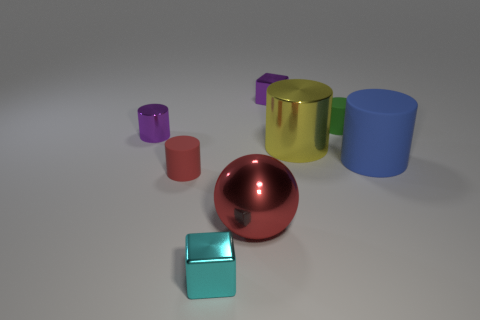Subtract all tiny green rubber cylinders. How many cylinders are left? 4 Subtract all red cylinders. How many cylinders are left? 4 Subtract all cyan cylinders. Subtract all purple blocks. How many cylinders are left? 5 Add 1 small cyan objects. How many objects exist? 9 Subtract all balls. How many objects are left? 7 Add 6 tiny rubber things. How many tiny rubber things exist? 8 Subtract 0 gray balls. How many objects are left? 8 Subtract all large purple rubber balls. Subtract all small cyan metal blocks. How many objects are left? 7 Add 4 tiny red matte objects. How many tiny red matte objects are left? 5 